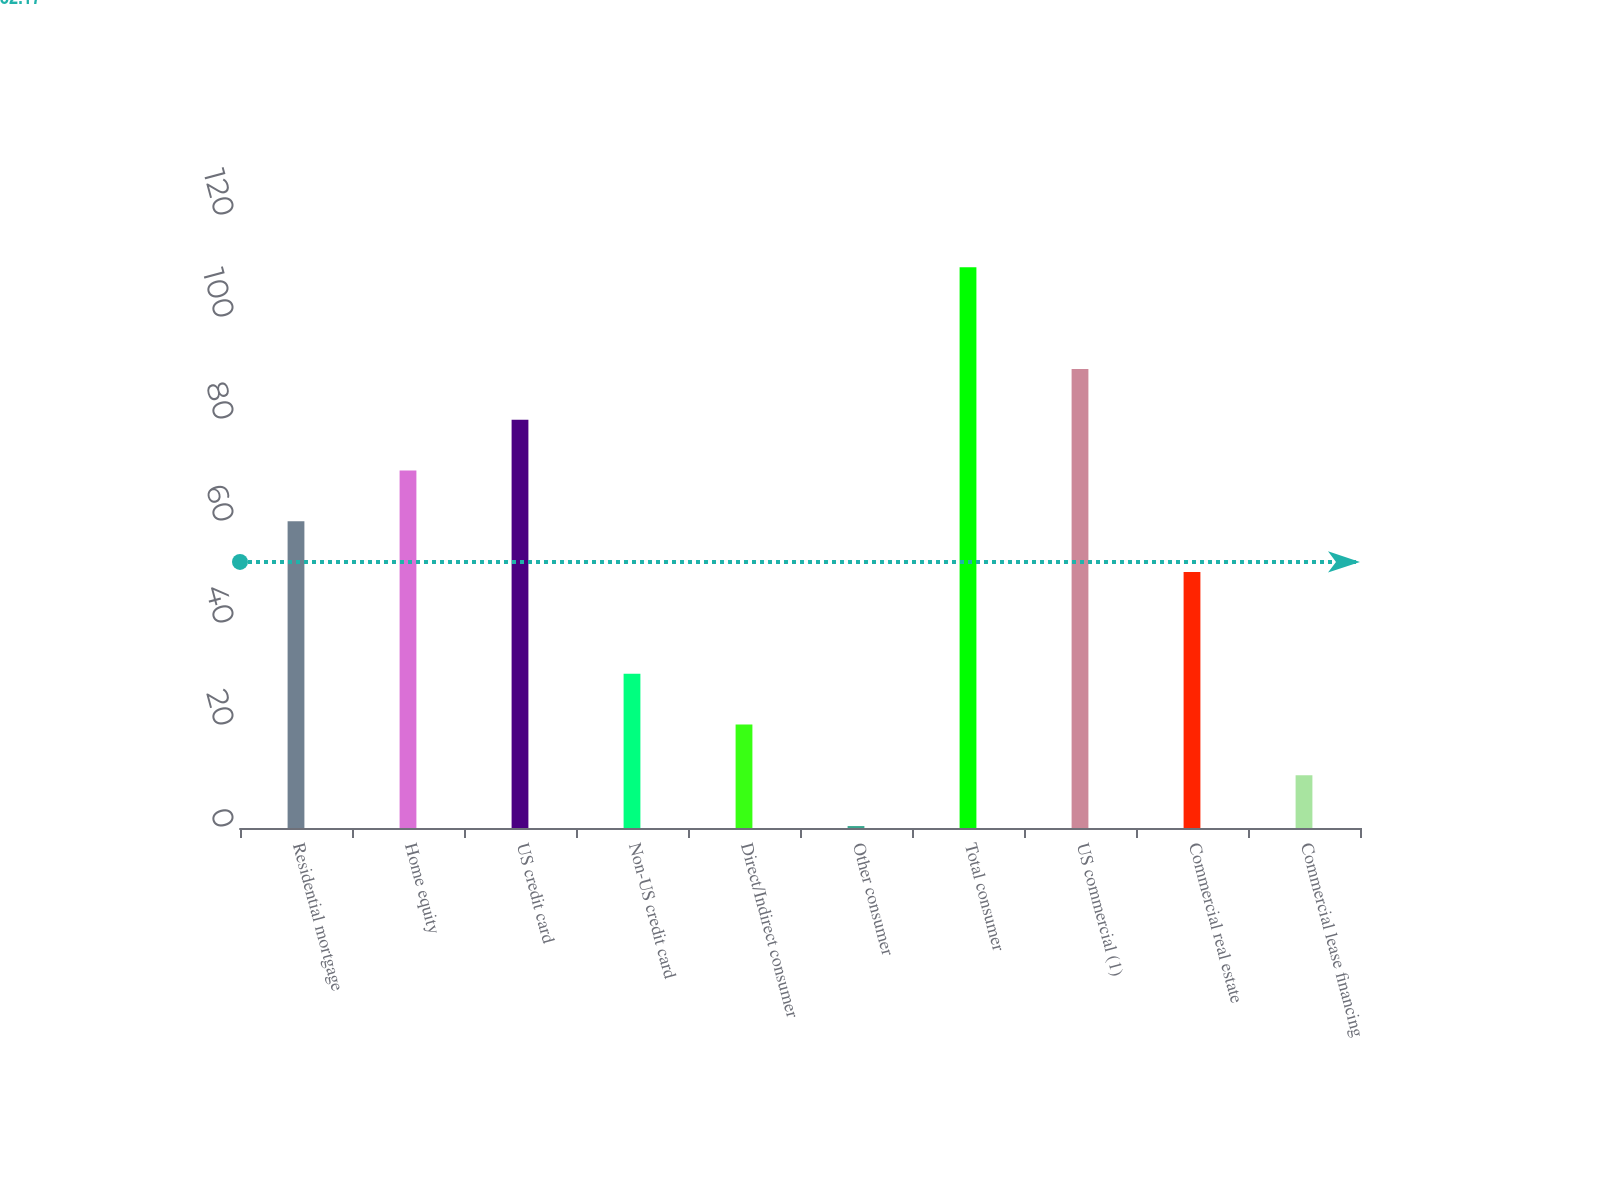<chart> <loc_0><loc_0><loc_500><loc_500><bar_chart><fcel>Residential mortgage<fcel>Home equity<fcel>US credit card<fcel>Non-US credit card<fcel>Direct/Indirect consumer<fcel>Other consumer<fcel>Total consumer<fcel>US commercial (1)<fcel>Commercial real estate<fcel>Commercial lease financing<nl><fcel>60.14<fcel>70.1<fcel>80.06<fcel>30.26<fcel>20.3<fcel>0.38<fcel>109.94<fcel>90.02<fcel>50.18<fcel>10.34<nl></chart> 